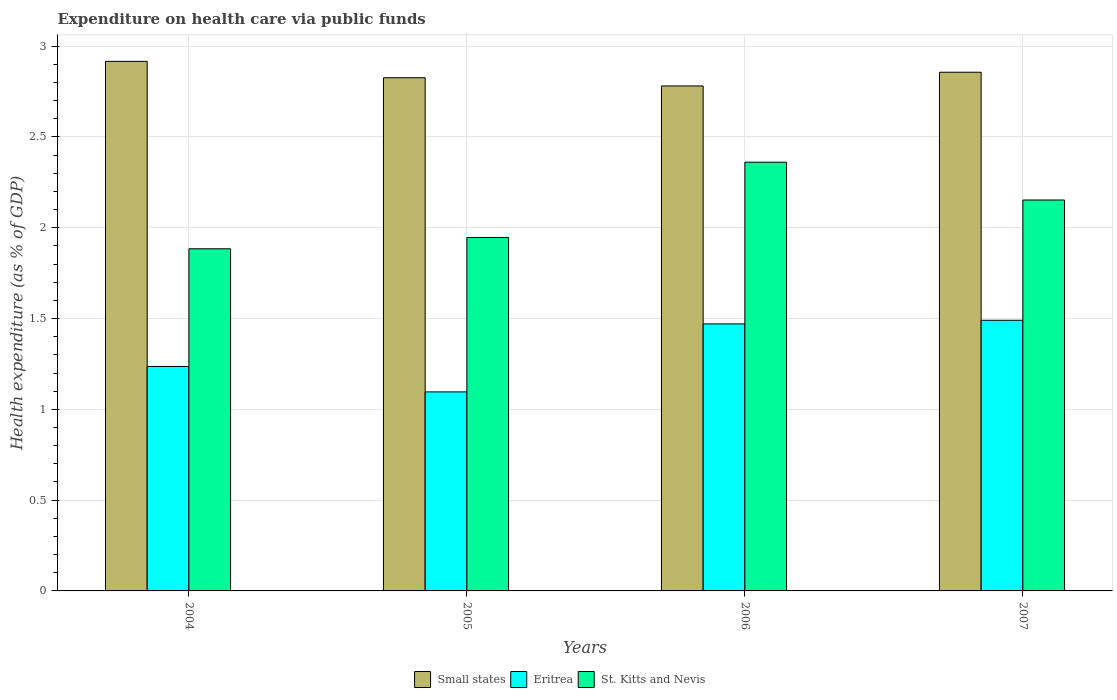How many different coloured bars are there?
Provide a short and direct response. 3. How many groups of bars are there?
Your answer should be very brief. 4. What is the expenditure made on health care in St. Kitts and Nevis in 2006?
Make the answer very short. 2.36. Across all years, what is the maximum expenditure made on health care in Small states?
Provide a short and direct response. 2.92. Across all years, what is the minimum expenditure made on health care in Small states?
Your answer should be very brief. 2.78. In which year was the expenditure made on health care in Eritrea maximum?
Keep it short and to the point. 2007. What is the total expenditure made on health care in Small states in the graph?
Ensure brevity in your answer.  11.38. What is the difference between the expenditure made on health care in Small states in 2004 and that in 2007?
Your answer should be very brief. 0.06. What is the difference between the expenditure made on health care in Small states in 2005 and the expenditure made on health care in Eritrea in 2004?
Ensure brevity in your answer.  1.59. What is the average expenditure made on health care in Small states per year?
Your answer should be compact. 2.84. In the year 2005, what is the difference between the expenditure made on health care in Eritrea and expenditure made on health care in Small states?
Keep it short and to the point. -1.73. In how many years, is the expenditure made on health care in Small states greater than 0.1 %?
Your response must be concise. 4. What is the ratio of the expenditure made on health care in Eritrea in 2004 to that in 2005?
Offer a very short reply. 1.13. Is the difference between the expenditure made on health care in Eritrea in 2004 and 2006 greater than the difference between the expenditure made on health care in Small states in 2004 and 2006?
Provide a succinct answer. No. What is the difference between the highest and the second highest expenditure made on health care in St. Kitts and Nevis?
Provide a short and direct response. 0.21. What is the difference between the highest and the lowest expenditure made on health care in Eritrea?
Ensure brevity in your answer.  0.39. In how many years, is the expenditure made on health care in Eritrea greater than the average expenditure made on health care in Eritrea taken over all years?
Ensure brevity in your answer.  2. Is the sum of the expenditure made on health care in Eritrea in 2005 and 2007 greater than the maximum expenditure made on health care in Small states across all years?
Give a very brief answer. No. What does the 2nd bar from the left in 2007 represents?
Your answer should be very brief. Eritrea. What does the 2nd bar from the right in 2007 represents?
Ensure brevity in your answer.  Eritrea. How many bars are there?
Make the answer very short. 12. Are all the bars in the graph horizontal?
Your response must be concise. No. Where does the legend appear in the graph?
Your response must be concise. Bottom center. How many legend labels are there?
Provide a short and direct response. 3. How are the legend labels stacked?
Make the answer very short. Horizontal. What is the title of the graph?
Give a very brief answer. Expenditure on health care via public funds. Does "Latin America(all income levels)" appear as one of the legend labels in the graph?
Provide a succinct answer. No. What is the label or title of the Y-axis?
Your response must be concise. Health expenditure (as % of GDP). What is the Health expenditure (as % of GDP) of Small states in 2004?
Offer a very short reply. 2.92. What is the Health expenditure (as % of GDP) in Eritrea in 2004?
Offer a terse response. 1.24. What is the Health expenditure (as % of GDP) in St. Kitts and Nevis in 2004?
Ensure brevity in your answer.  1.88. What is the Health expenditure (as % of GDP) in Small states in 2005?
Ensure brevity in your answer.  2.83. What is the Health expenditure (as % of GDP) of Eritrea in 2005?
Make the answer very short. 1.1. What is the Health expenditure (as % of GDP) of St. Kitts and Nevis in 2005?
Provide a succinct answer. 1.95. What is the Health expenditure (as % of GDP) of Small states in 2006?
Your answer should be compact. 2.78. What is the Health expenditure (as % of GDP) in Eritrea in 2006?
Your answer should be very brief. 1.47. What is the Health expenditure (as % of GDP) of St. Kitts and Nevis in 2006?
Provide a succinct answer. 2.36. What is the Health expenditure (as % of GDP) of Small states in 2007?
Give a very brief answer. 2.86. What is the Health expenditure (as % of GDP) in Eritrea in 2007?
Provide a short and direct response. 1.49. What is the Health expenditure (as % of GDP) of St. Kitts and Nevis in 2007?
Provide a succinct answer. 2.15. Across all years, what is the maximum Health expenditure (as % of GDP) of Small states?
Keep it short and to the point. 2.92. Across all years, what is the maximum Health expenditure (as % of GDP) in Eritrea?
Offer a very short reply. 1.49. Across all years, what is the maximum Health expenditure (as % of GDP) of St. Kitts and Nevis?
Make the answer very short. 2.36. Across all years, what is the minimum Health expenditure (as % of GDP) in Small states?
Offer a terse response. 2.78. Across all years, what is the minimum Health expenditure (as % of GDP) in Eritrea?
Keep it short and to the point. 1.1. Across all years, what is the minimum Health expenditure (as % of GDP) of St. Kitts and Nevis?
Offer a terse response. 1.88. What is the total Health expenditure (as % of GDP) in Small states in the graph?
Ensure brevity in your answer.  11.38. What is the total Health expenditure (as % of GDP) in Eritrea in the graph?
Your response must be concise. 5.29. What is the total Health expenditure (as % of GDP) of St. Kitts and Nevis in the graph?
Provide a succinct answer. 8.34. What is the difference between the Health expenditure (as % of GDP) of Small states in 2004 and that in 2005?
Offer a very short reply. 0.09. What is the difference between the Health expenditure (as % of GDP) of Eritrea in 2004 and that in 2005?
Provide a succinct answer. 0.14. What is the difference between the Health expenditure (as % of GDP) of St. Kitts and Nevis in 2004 and that in 2005?
Your answer should be very brief. -0.06. What is the difference between the Health expenditure (as % of GDP) of Small states in 2004 and that in 2006?
Your response must be concise. 0.14. What is the difference between the Health expenditure (as % of GDP) in Eritrea in 2004 and that in 2006?
Ensure brevity in your answer.  -0.23. What is the difference between the Health expenditure (as % of GDP) in St. Kitts and Nevis in 2004 and that in 2006?
Give a very brief answer. -0.48. What is the difference between the Health expenditure (as % of GDP) of Small states in 2004 and that in 2007?
Make the answer very short. 0.06. What is the difference between the Health expenditure (as % of GDP) of Eritrea in 2004 and that in 2007?
Give a very brief answer. -0.25. What is the difference between the Health expenditure (as % of GDP) in St. Kitts and Nevis in 2004 and that in 2007?
Offer a terse response. -0.27. What is the difference between the Health expenditure (as % of GDP) of Small states in 2005 and that in 2006?
Provide a short and direct response. 0.05. What is the difference between the Health expenditure (as % of GDP) in Eritrea in 2005 and that in 2006?
Keep it short and to the point. -0.37. What is the difference between the Health expenditure (as % of GDP) in St. Kitts and Nevis in 2005 and that in 2006?
Your answer should be very brief. -0.41. What is the difference between the Health expenditure (as % of GDP) in Small states in 2005 and that in 2007?
Your response must be concise. -0.03. What is the difference between the Health expenditure (as % of GDP) of Eritrea in 2005 and that in 2007?
Your answer should be very brief. -0.39. What is the difference between the Health expenditure (as % of GDP) of St. Kitts and Nevis in 2005 and that in 2007?
Offer a very short reply. -0.21. What is the difference between the Health expenditure (as % of GDP) in Small states in 2006 and that in 2007?
Give a very brief answer. -0.08. What is the difference between the Health expenditure (as % of GDP) in Eritrea in 2006 and that in 2007?
Keep it short and to the point. -0.02. What is the difference between the Health expenditure (as % of GDP) in St. Kitts and Nevis in 2006 and that in 2007?
Your answer should be very brief. 0.21. What is the difference between the Health expenditure (as % of GDP) in Small states in 2004 and the Health expenditure (as % of GDP) in Eritrea in 2005?
Make the answer very short. 1.82. What is the difference between the Health expenditure (as % of GDP) in Small states in 2004 and the Health expenditure (as % of GDP) in St. Kitts and Nevis in 2005?
Keep it short and to the point. 0.97. What is the difference between the Health expenditure (as % of GDP) of Eritrea in 2004 and the Health expenditure (as % of GDP) of St. Kitts and Nevis in 2005?
Offer a terse response. -0.71. What is the difference between the Health expenditure (as % of GDP) of Small states in 2004 and the Health expenditure (as % of GDP) of Eritrea in 2006?
Give a very brief answer. 1.45. What is the difference between the Health expenditure (as % of GDP) in Small states in 2004 and the Health expenditure (as % of GDP) in St. Kitts and Nevis in 2006?
Provide a short and direct response. 0.56. What is the difference between the Health expenditure (as % of GDP) of Eritrea in 2004 and the Health expenditure (as % of GDP) of St. Kitts and Nevis in 2006?
Provide a succinct answer. -1.12. What is the difference between the Health expenditure (as % of GDP) of Small states in 2004 and the Health expenditure (as % of GDP) of Eritrea in 2007?
Ensure brevity in your answer.  1.43. What is the difference between the Health expenditure (as % of GDP) of Small states in 2004 and the Health expenditure (as % of GDP) of St. Kitts and Nevis in 2007?
Give a very brief answer. 0.76. What is the difference between the Health expenditure (as % of GDP) of Eritrea in 2004 and the Health expenditure (as % of GDP) of St. Kitts and Nevis in 2007?
Ensure brevity in your answer.  -0.92. What is the difference between the Health expenditure (as % of GDP) of Small states in 2005 and the Health expenditure (as % of GDP) of Eritrea in 2006?
Your response must be concise. 1.36. What is the difference between the Health expenditure (as % of GDP) in Small states in 2005 and the Health expenditure (as % of GDP) in St. Kitts and Nevis in 2006?
Give a very brief answer. 0.47. What is the difference between the Health expenditure (as % of GDP) of Eritrea in 2005 and the Health expenditure (as % of GDP) of St. Kitts and Nevis in 2006?
Provide a succinct answer. -1.27. What is the difference between the Health expenditure (as % of GDP) in Small states in 2005 and the Health expenditure (as % of GDP) in Eritrea in 2007?
Your answer should be very brief. 1.34. What is the difference between the Health expenditure (as % of GDP) of Small states in 2005 and the Health expenditure (as % of GDP) of St. Kitts and Nevis in 2007?
Your response must be concise. 0.67. What is the difference between the Health expenditure (as % of GDP) of Eritrea in 2005 and the Health expenditure (as % of GDP) of St. Kitts and Nevis in 2007?
Your response must be concise. -1.06. What is the difference between the Health expenditure (as % of GDP) of Small states in 2006 and the Health expenditure (as % of GDP) of Eritrea in 2007?
Your response must be concise. 1.29. What is the difference between the Health expenditure (as % of GDP) of Small states in 2006 and the Health expenditure (as % of GDP) of St. Kitts and Nevis in 2007?
Make the answer very short. 0.63. What is the difference between the Health expenditure (as % of GDP) in Eritrea in 2006 and the Health expenditure (as % of GDP) in St. Kitts and Nevis in 2007?
Your answer should be compact. -0.68. What is the average Health expenditure (as % of GDP) in Small states per year?
Your response must be concise. 2.84. What is the average Health expenditure (as % of GDP) in Eritrea per year?
Provide a succinct answer. 1.32. What is the average Health expenditure (as % of GDP) in St. Kitts and Nevis per year?
Ensure brevity in your answer.  2.09. In the year 2004, what is the difference between the Health expenditure (as % of GDP) in Small states and Health expenditure (as % of GDP) in Eritrea?
Keep it short and to the point. 1.68. In the year 2004, what is the difference between the Health expenditure (as % of GDP) in Small states and Health expenditure (as % of GDP) in St. Kitts and Nevis?
Offer a very short reply. 1.03. In the year 2004, what is the difference between the Health expenditure (as % of GDP) of Eritrea and Health expenditure (as % of GDP) of St. Kitts and Nevis?
Your answer should be compact. -0.65. In the year 2005, what is the difference between the Health expenditure (as % of GDP) of Small states and Health expenditure (as % of GDP) of Eritrea?
Your answer should be very brief. 1.73. In the year 2005, what is the difference between the Health expenditure (as % of GDP) in Small states and Health expenditure (as % of GDP) in St. Kitts and Nevis?
Your response must be concise. 0.88. In the year 2005, what is the difference between the Health expenditure (as % of GDP) of Eritrea and Health expenditure (as % of GDP) of St. Kitts and Nevis?
Your answer should be compact. -0.85. In the year 2006, what is the difference between the Health expenditure (as % of GDP) of Small states and Health expenditure (as % of GDP) of Eritrea?
Your answer should be compact. 1.31. In the year 2006, what is the difference between the Health expenditure (as % of GDP) of Small states and Health expenditure (as % of GDP) of St. Kitts and Nevis?
Give a very brief answer. 0.42. In the year 2006, what is the difference between the Health expenditure (as % of GDP) of Eritrea and Health expenditure (as % of GDP) of St. Kitts and Nevis?
Provide a short and direct response. -0.89. In the year 2007, what is the difference between the Health expenditure (as % of GDP) in Small states and Health expenditure (as % of GDP) in Eritrea?
Your response must be concise. 1.37. In the year 2007, what is the difference between the Health expenditure (as % of GDP) in Small states and Health expenditure (as % of GDP) in St. Kitts and Nevis?
Your response must be concise. 0.7. In the year 2007, what is the difference between the Health expenditure (as % of GDP) of Eritrea and Health expenditure (as % of GDP) of St. Kitts and Nevis?
Provide a short and direct response. -0.66. What is the ratio of the Health expenditure (as % of GDP) of Small states in 2004 to that in 2005?
Your answer should be very brief. 1.03. What is the ratio of the Health expenditure (as % of GDP) in Eritrea in 2004 to that in 2005?
Provide a short and direct response. 1.13. What is the ratio of the Health expenditure (as % of GDP) of St. Kitts and Nevis in 2004 to that in 2005?
Your answer should be compact. 0.97. What is the ratio of the Health expenditure (as % of GDP) in Small states in 2004 to that in 2006?
Keep it short and to the point. 1.05. What is the ratio of the Health expenditure (as % of GDP) of Eritrea in 2004 to that in 2006?
Provide a short and direct response. 0.84. What is the ratio of the Health expenditure (as % of GDP) in St. Kitts and Nevis in 2004 to that in 2006?
Give a very brief answer. 0.8. What is the ratio of the Health expenditure (as % of GDP) in Small states in 2004 to that in 2007?
Ensure brevity in your answer.  1.02. What is the ratio of the Health expenditure (as % of GDP) in Eritrea in 2004 to that in 2007?
Provide a short and direct response. 0.83. What is the ratio of the Health expenditure (as % of GDP) in St. Kitts and Nevis in 2004 to that in 2007?
Offer a terse response. 0.88. What is the ratio of the Health expenditure (as % of GDP) of Small states in 2005 to that in 2006?
Make the answer very short. 1.02. What is the ratio of the Health expenditure (as % of GDP) of Eritrea in 2005 to that in 2006?
Offer a very short reply. 0.75. What is the ratio of the Health expenditure (as % of GDP) in St. Kitts and Nevis in 2005 to that in 2006?
Provide a succinct answer. 0.82. What is the ratio of the Health expenditure (as % of GDP) of Small states in 2005 to that in 2007?
Provide a short and direct response. 0.99. What is the ratio of the Health expenditure (as % of GDP) of Eritrea in 2005 to that in 2007?
Offer a terse response. 0.74. What is the ratio of the Health expenditure (as % of GDP) in St. Kitts and Nevis in 2005 to that in 2007?
Provide a short and direct response. 0.9. What is the ratio of the Health expenditure (as % of GDP) of Small states in 2006 to that in 2007?
Provide a succinct answer. 0.97. What is the ratio of the Health expenditure (as % of GDP) in Eritrea in 2006 to that in 2007?
Your answer should be very brief. 0.99. What is the ratio of the Health expenditure (as % of GDP) of St. Kitts and Nevis in 2006 to that in 2007?
Make the answer very short. 1.1. What is the difference between the highest and the second highest Health expenditure (as % of GDP) of Small states?
Offer a terse response. 0.06. What is the difference between the highest and the second highest Health expenditure (as % of GDP) in Eritrea?
Provide a succinct answer. 0.02. What is the difference between the highest and the second highest Health expenditure (as % of GDP) of St. Kitts and Nevis?
Provide a succinct answer. 0.21. What is the difference between the highest and the lowest Health expenditure (as % of GDP) of Small states?
Your answer should be compact. 0.14. What is the difference between the highest and the lowest Health expenditure (as % of GDP) of Eritrea?
Make the answer very short. 0.39. What is the difference between the highest and the lowest Health expenditure (as % of GDP) in St. Kitts and Nevis?
Offer a very short reply. 0.48. 